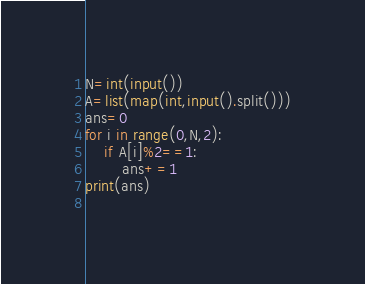<code> <loc_0><loc_0><loc_500><loc_500><_Python_>N=int(input())
A=list(map(int,input().split()))
ans=0
for i in range(0,N,2):
    if A[i]%2==1:
        ans+=1
print(ans)
    </code> 